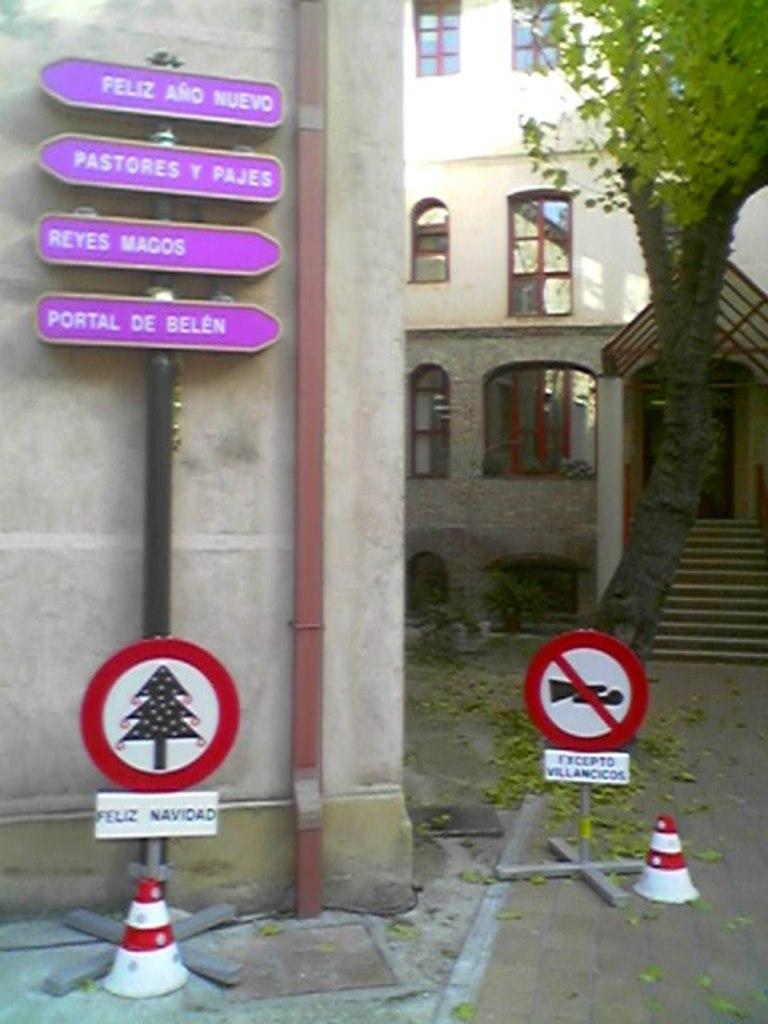What is the phrase on the red sign on the left?
Offer a terse response. Feliz navidad. 